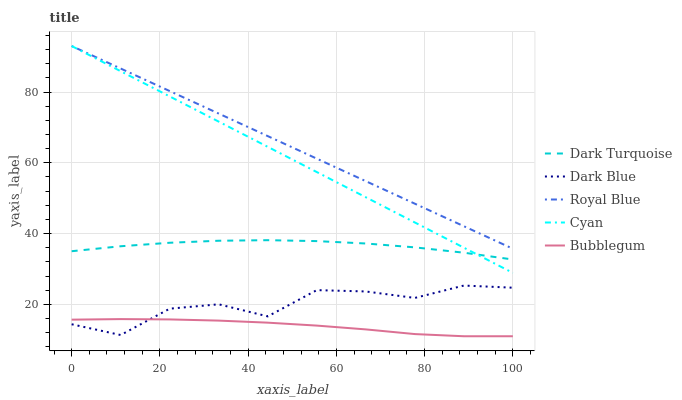Does Bubblegum have the minimum area under the curve?
Answer yes or no. Yes. Does Royal Blue have the maximum area under the curve?
Answer yes or no. Yes. Does Cyan have the minimum area under the curve?
Answer yes or no. No. Does Cyan have the maximum area under the curve?
Answer yes or no. No. Is Royal Blue the smoothest?
Answer yes or no. Yes. Is Dark Blue the roughest?
Answer yes or no. Yes. Is Cyan the smoothest?
Answer yes or no. No. Is Cyan the roughest?
Answer yes or no. No. Does Bubblegum have the lowest value?
Answer yes or no. Yes. Does Cyan have the lowest value?
Answer yes or no. No. Does Royal Blue have the highest value?
Answer yes or no. Yes. Does Bubblegum have the highest value?
Answer yes or no. No. Is Dark Blue less than Cyan?
Answer yes or no. Yes. Is Royal Blue greater than Dark Turquoise?
Answer yes or no. Yes. Does Cyan intersect Royal Blue?
Answer yes or no. Yes. Is Cyan less than Royal Blue?
Answer yes or no. No. Is Cyan greater than Royal Blue?
Answer yes or no. No. Does Dark Blue intersect Cyan?
Answer yes or no. No. 